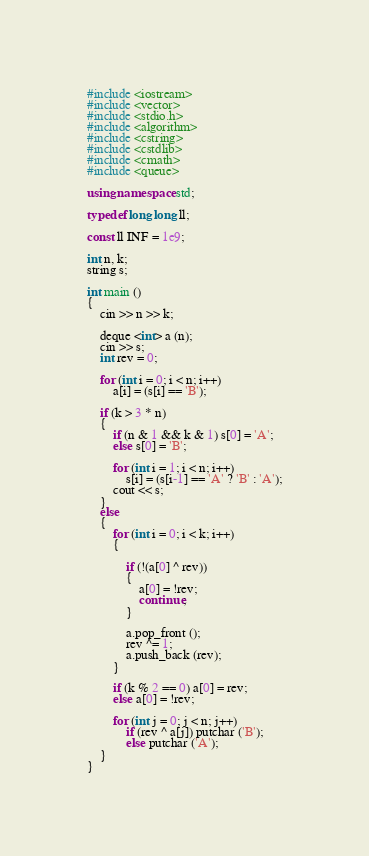Convert code to text. <code><loc_0><loc_0><loc_500><loc_500><_C++_>#include <iostream>
#include <vector>
#include <stdio.h>
#include <algorithm>
#include <cstring>
#include <cstdlib>
#include <cmath>
#include <queue>
 
using namespace std;
 
typedef long long ll;
 
const ll INF = 1e9;
 
int n, k;
string s;
 
int main ()
{
	cin >> n >> k;

	deque <int> a (n);
	cin >> s;
	int rev = 0;

	for (int i = 0; i < n; i++)
		a[i] = (s[i] == 'B');

	if (k > 3 * n)
	{
		if (n & 1 && k & 1) s[0] = 'A';
		else s[0] = 'B';

		for (int i = 1; i < n; i++)
			s[i] = (s[i-1] == 'A' ? 'B' : 'A');
		cout << s;
	}
	else
	{
		for (int i = 0; i < k; i++)
		{

			if (!(a[0] ^ rev)) 
			{
				a[0] = !rev;
				continue;
			}

			a.pop_front ();
			rev ^= 1;
			a.push_back (rev);
		}

		if (k % 2 == 0) a[0] = rev;
		else a[0] = !rev;

		for (int j = 0; j < n; j++)
			if (rev ^ a[j]) putchar ('B');
			else putchar ('A');
	}
}</code> 